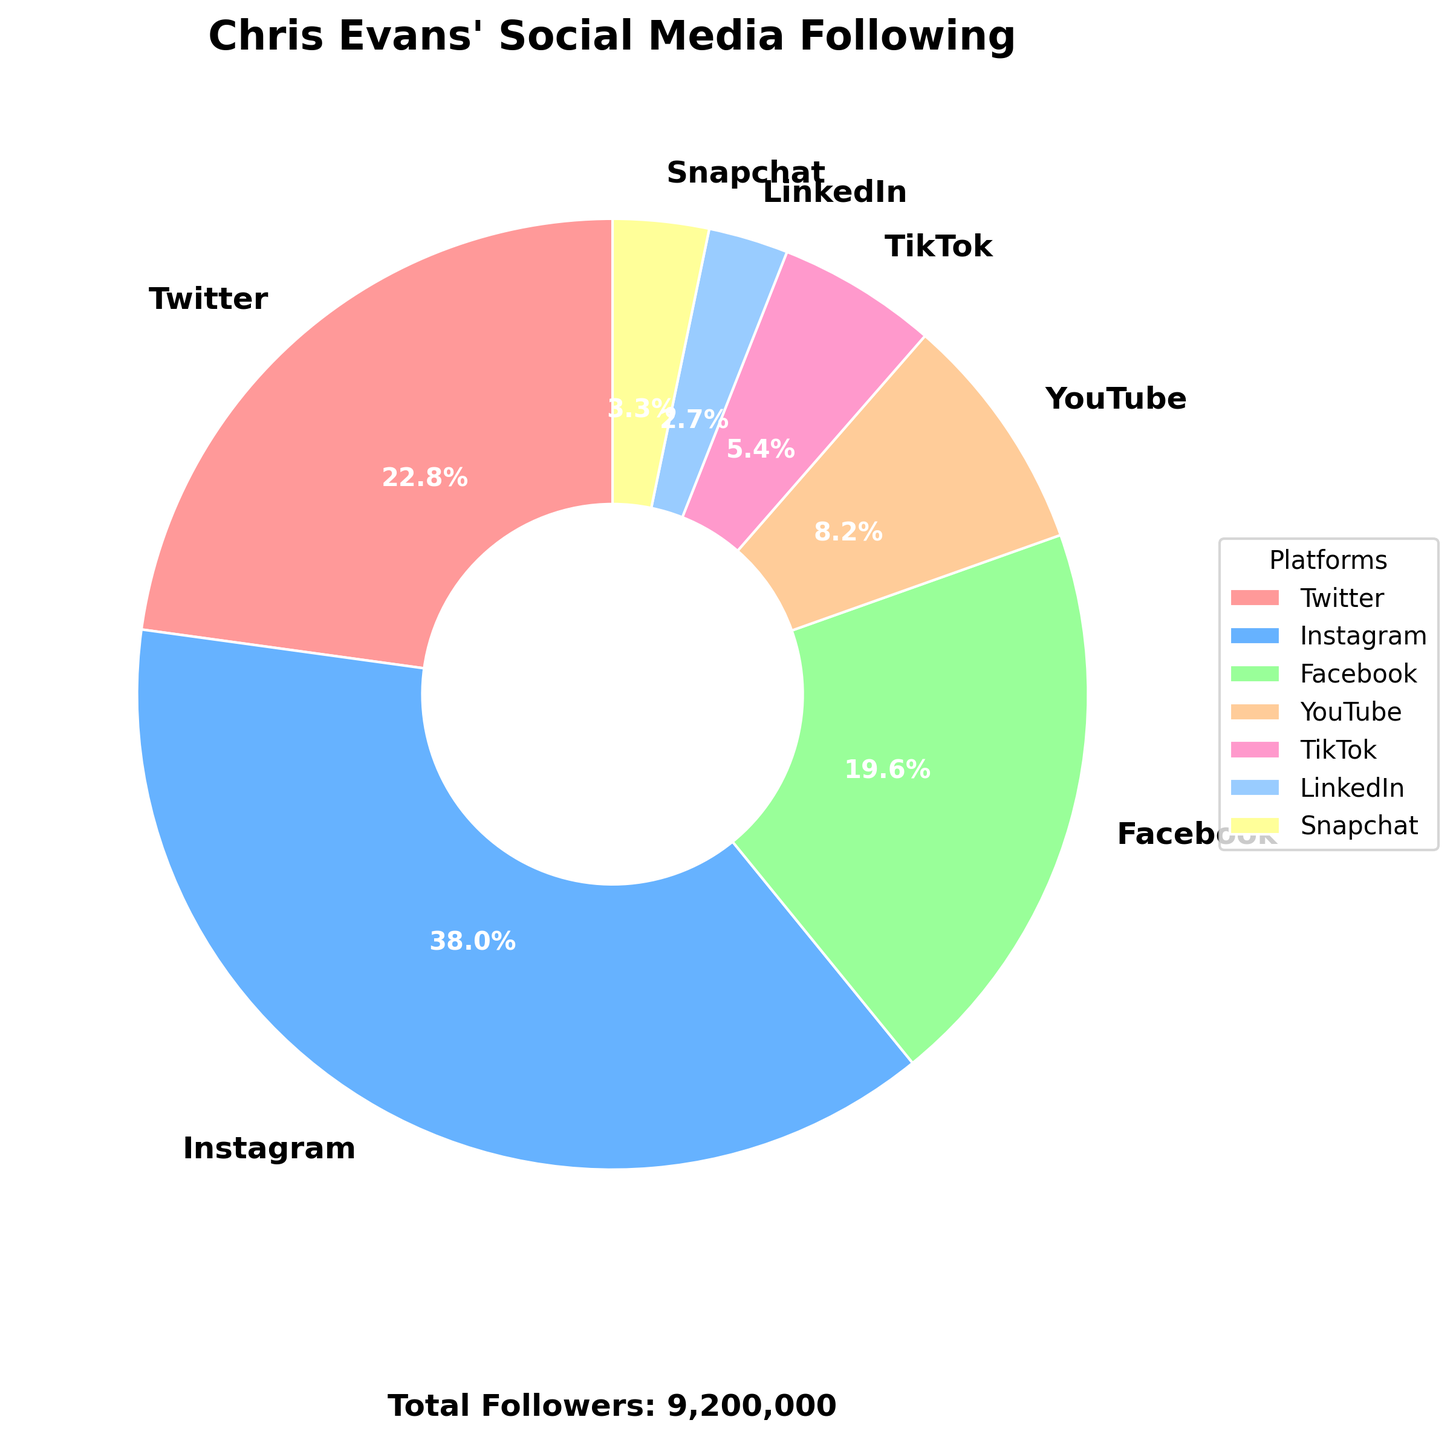What platform has the highest percentage of followers? The pie chart shows different percentages for each platform. The platform with the highest percentage is Instagram.
Answer: Instagram Which two platforms together almost make up half of the total followers? Adding up the percentages of Instagram (42.7%) and Twitter (25.6%) from the chart gives a total of 68.3%, which is significantly more than half. Check if Instagram and Facebook together are closer: 42.7% + 22.0% = 64.7%. The pair Twitter (25.6%) and Facebook (22.0%) together make 47.6%, which is closest to half.
Answer: Twitter and Facebook Which platform has more followers: TikTok or YouTube? The chart shows a segment for YouTube and TikTok. The percentage for YouTube (9.1%) is larger than TikTok (6.1%).
Answer: YouTube What is the size of Chris Evans' LinkedIn following as a percentage of his total following? Find the LinkedIn segment in the chart and note the percentage shown, which is 3.0%.
Answer: 3.0% Which platforms have less than 10% of the total followers? On the chart, analyze each segment with a value less than 10%. These include TikTok (6.1%), LinkedIn (3.0%), Snapchat (3.7%), and YouTube (9.1%).
Answer: TikTok, LinkedIn, Snapchat, YouTube Is the number of Instagram followers more than double the number of Twitter followers? Instagram has 3,500,000 followers and Twitter has 2,100,000 followers. Doubling the Twitter followers gives 4,200,000, which is indeed more than 3,500,000. Hence, Instagram is less than double Twitter followers.
Answer: No How does the Snapchat following compare to the LinkedIn following? Compare the percentages of the pie chart for both Snapchat (3.7%) and LinkedIn (3.0%). Snapchat has a slightly larger percentage of followers.
Answer: Snapchat has more What's the combined percentage of Chris Evans' followers on Facebook and TikTok? Add the percentages from the chart: Facebook's 22.0% and TikTok's 6.1%. This gives a combined percentage of 28.1%.
Answer: 28.1% Rank the platforms from most followers to least followers. Based on the percentage sizes in the pie chart, rank them: Instagram, Twitter, Facebook, YouTube, TikTok, Snapchat, LinkedIn.
Answer: Instagram > Twitter > Facebook > YouTube > TikTok > Snapchat > LinkedIn What's the difference in the number of followers between Snapchat and LinkedIn? Subtract the number of LinkedIn followers (250,000) from the number of Snapchat followers (300,000), which gives 50,000.
Answer: 50,000 